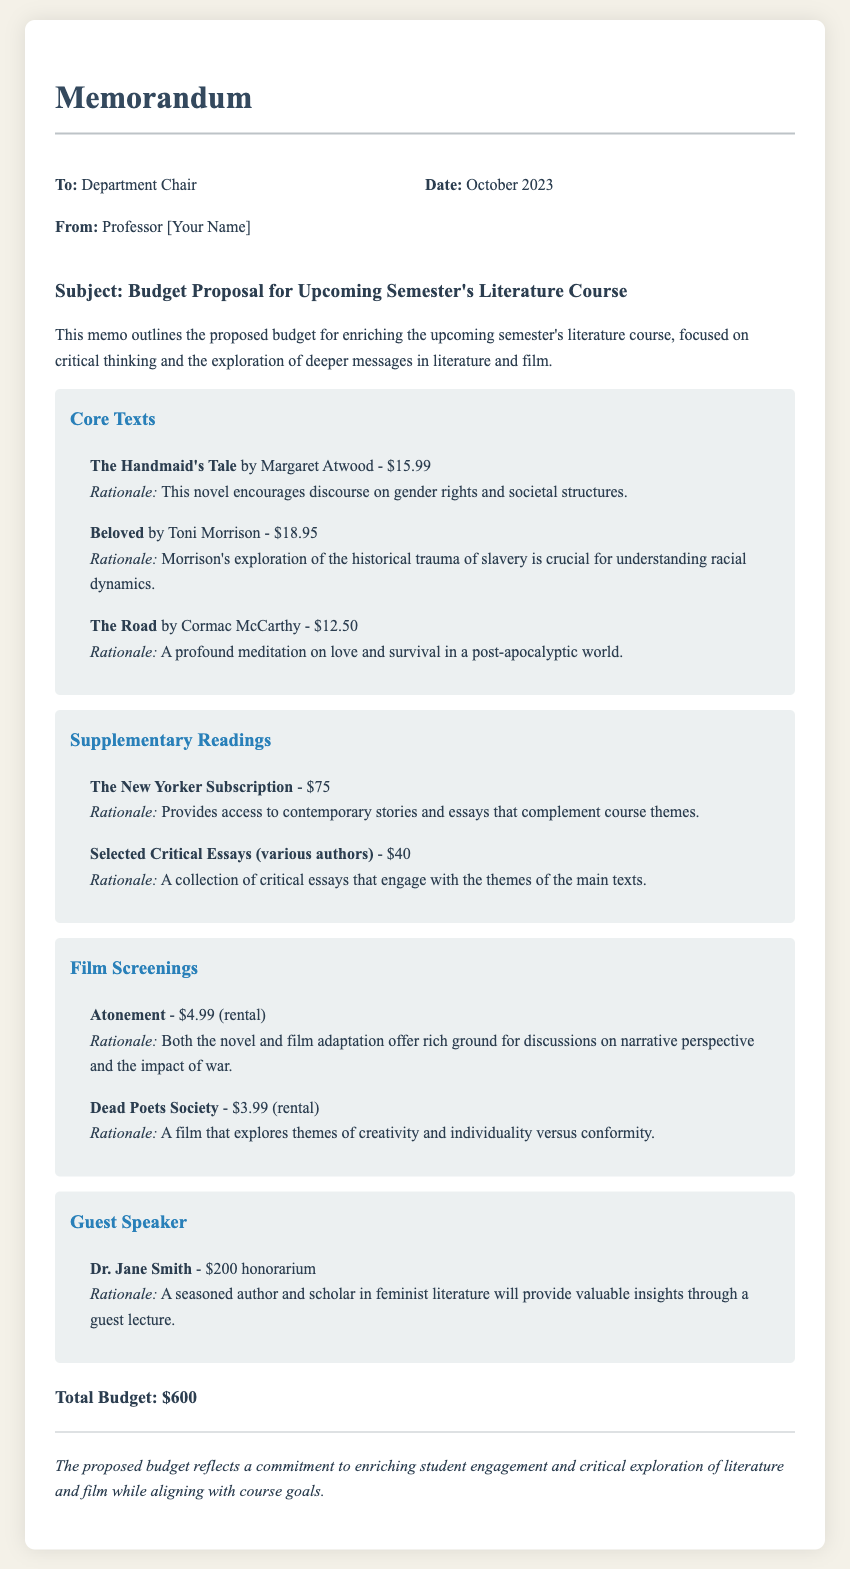What is the total budget? The total budget is stated at the end of the memo, summarizing all proposed expenses.
Answer: $600 Who is the guest speaker? The memo mentions a guest speaker along with their credentials.
Answer: Dr. Jane Smith What is the price of "Beloved"? The price of this core text is specifically listed in the budget section.
Answer: $18.95 What type of subscription is included in the supplementary readings? The memo details the type of reading material for the course, including the subscription.
Answer: The New Yorker Subscription What themes are explored in "Dead Poets Society"? The rationale provided gives insight into the themes discussed in the film.
Answer: Creativity and individuality versus conformity What is the rationale for including "The Handmaid's Tale"? This provides insight into why the text is chosen for the course, indicating its relevance.
Answer: Encourages discourse on gender rights and societal structures How much is the honorarium for the guest speaker? The budget document specifies the amount allocated for the guest speaker.
Answer: $200 Which film is mentioned alongside "Atonement"? The memo lists two films with their respective rationales.
Answer: Dead Poets Society What type of materials does the collection of selected critical essays include? The memo specifies the nature of the supplementary materials for the course.
Answer: Various authors 